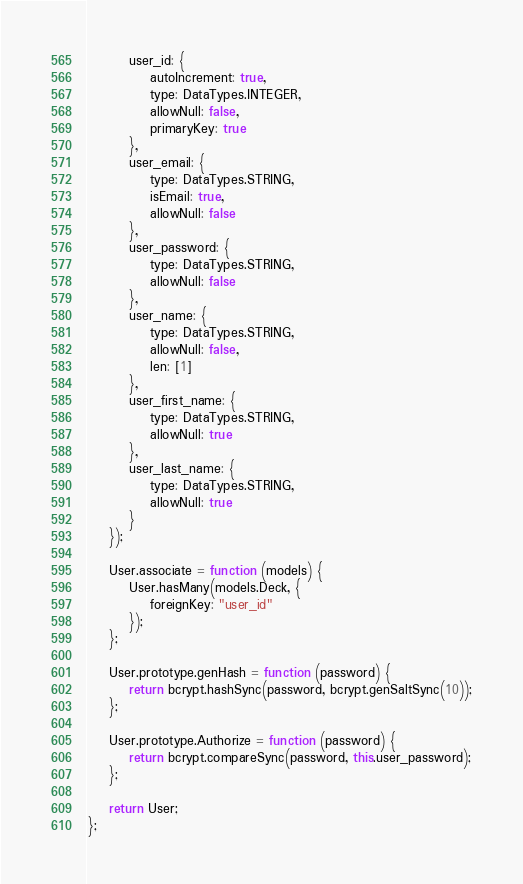Convert code to text. <code><loc_0><loc_0><loc_500><loc_500><_JavaScript_>        user_id: {
            autoIncrement: true,
            type: DataTypes.INTEGER,
            allowNull: false,
            primaryKey: true
        },
        user_email: {
            type: DataTypes.STRING,
            isEmail: true,
            allowNull: false
        },
        user_password: {
            type: DataTypes.STRING,
            allowNull: false
        },
        user_name: {
            type: DataTypes.STRING,
            allowNull: false,
            len: [1]
        },
        user_first_name: {
            type: DataTypes.STRING,
            allowNull: true
        },
        user_last_name: {
            type: DataTypes.STRING,
            allowNull: true
        }
    });

    User.associate = function (models) {
        User.hasMany(models.Deck, {
            foreignKey: "user_id"
        });
    };

    User.prototype.genHash = function (password) {
        return bcrypt.hashSync(password, bcrypt.genSaltSync(10));
    };

    User.prototype.Authorize = function (password) {
        return bcrypt.compareSync(password, this.user_password);
    };

    return User;
};</code> 